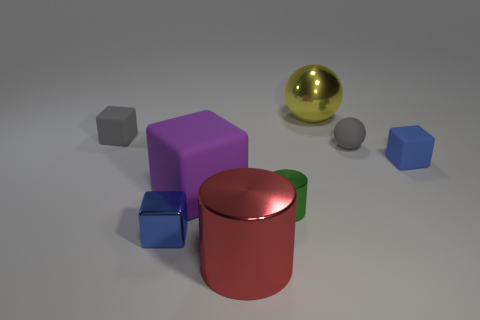How many blue cubes must be subtracted to get 1 blue cubes? 1 Subtract all tiny gray blocks. How many blocks are left? 3 Subtract 1 cylinders. How many cylinders are left? 1 Subtract all green cylinders. How many cylinders are left? 1 Add 1 purple rubber blocks. How many objects exist? 9 Subtract all cylinders. How many objects are left? 6 Add 4 large blue matte balls. How many large blue matte balls exist? 4 Subtract 0 yellow cylinders. How many objects are left? 8 Subtract all purple balls. Subtract all yellow blocks. How many balls are left? 2 Subtract all red blocks. How many red spheres are left? 0 